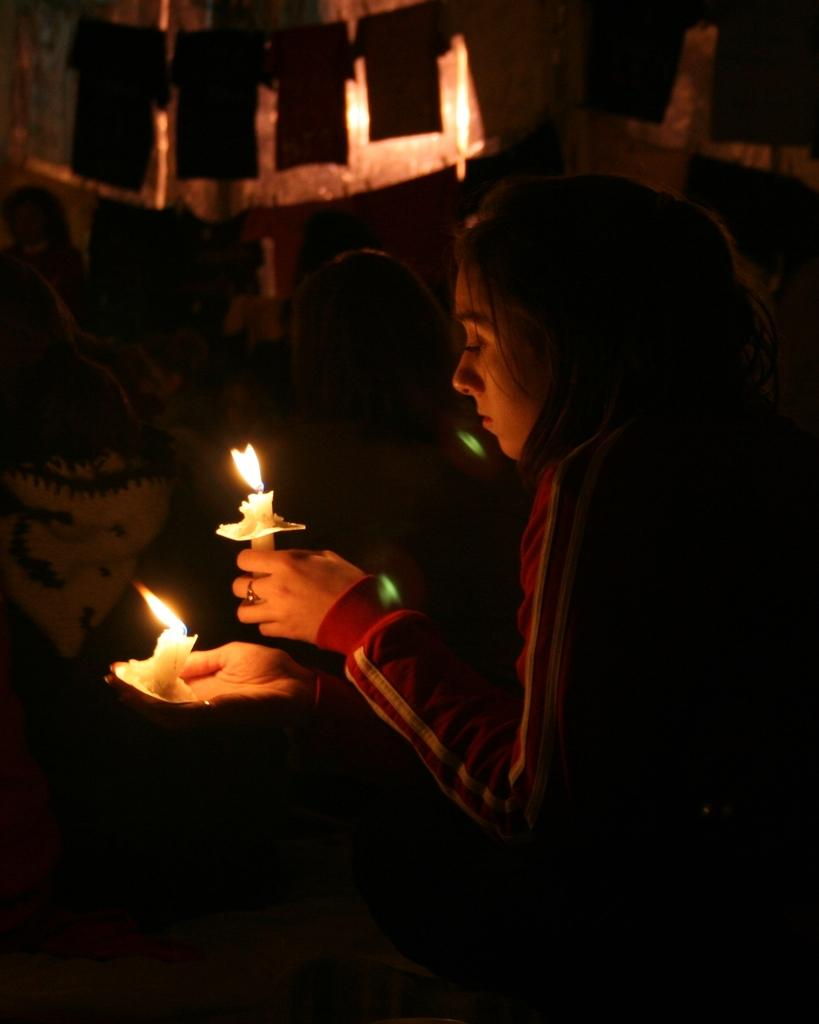What is the main subject of the image? The main subject of the image is people standing. Can you describe the woman in the image? There is a woman in the image, and she is holding candles in her hand. What type of fruit is the woman holding in the image? The woman is not holding any fruit in the image; she is holding candles. Is there a club visible in the image? There is no club present in the image. 